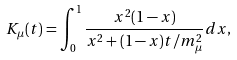Convert formula to latex. <formula><loc_0><loc_0><loc_500><loc_500>K _ { \mu } ( t ) = \int _ { 0 } ^ { 1 } \frac { x ^ { 2 } ( 1 - x ) } { x ^ { 2 } + ( 1 - x ) t / m _ { \mu } ^ { 2 } } d x ,</formula> 